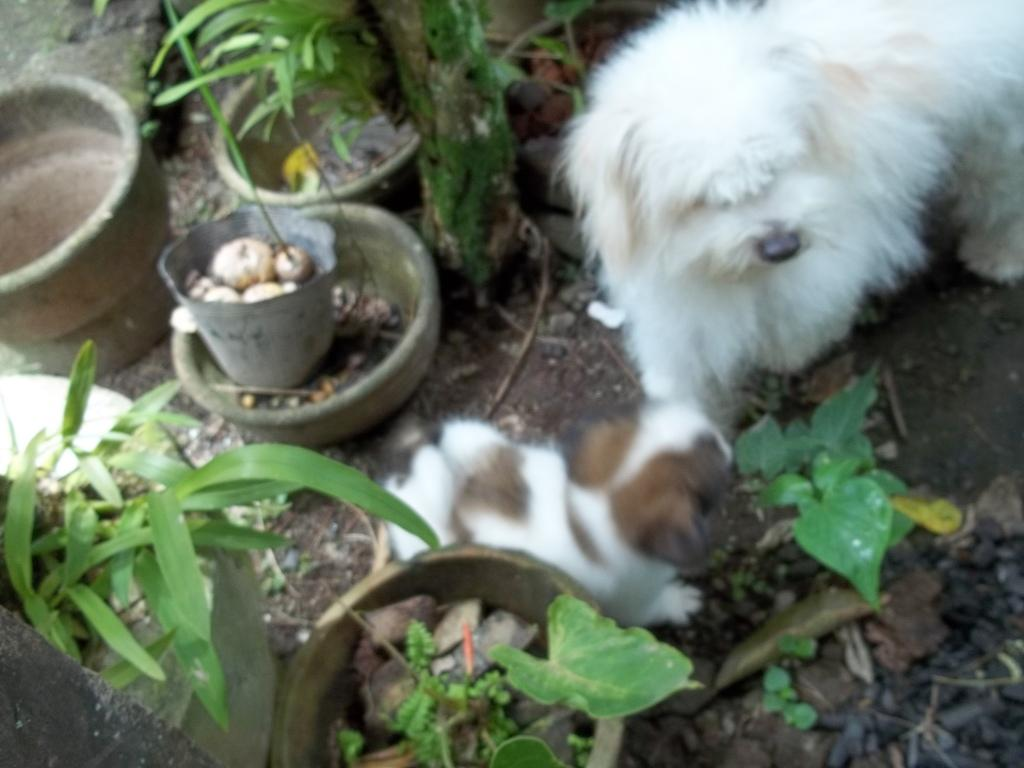What type of animal can be seen in the image? There is a dog and a puppy in the image. What are the plants in the image placed in? The plants are placed in flower pots. Where is the pot located in the image? There is a pot on the left side of the image. What type of stitch is used to sew the dog's collar in the image? There is no information about the dog's collar or any stitching in the image. 